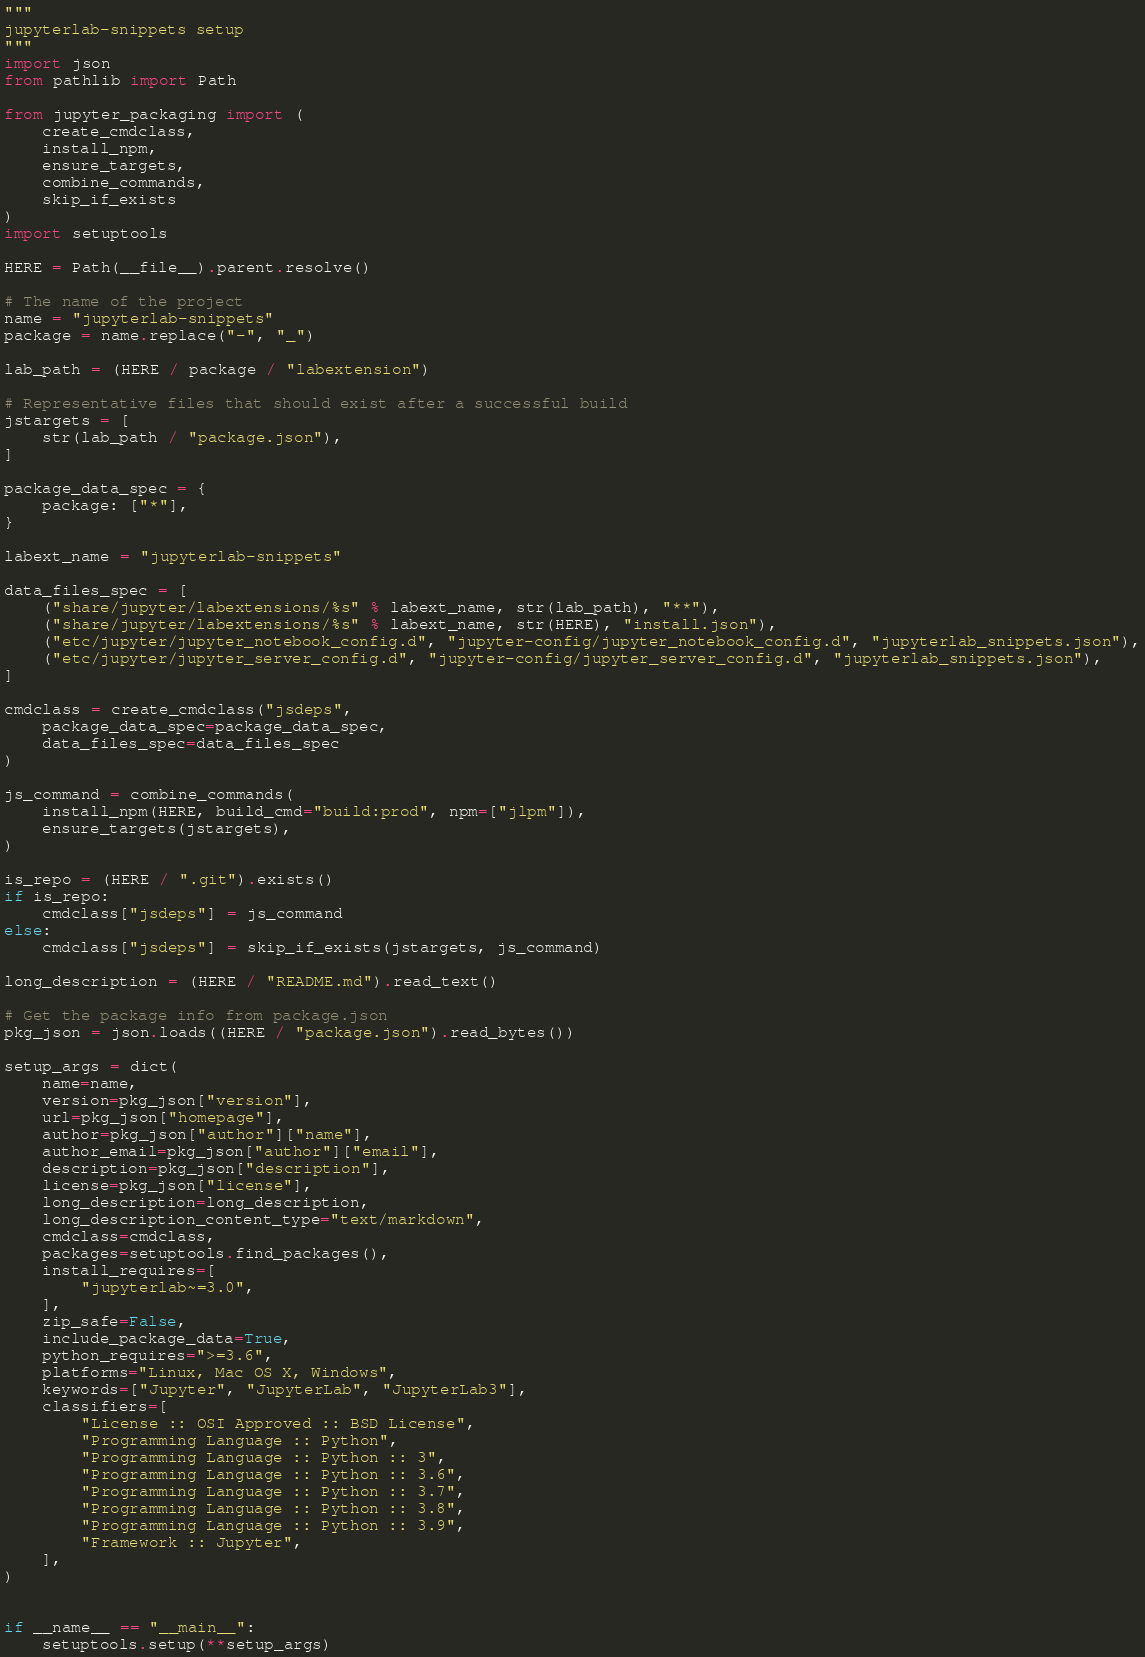<code> <loc_0><loc_0><loc_500><loc_500><_Python_>"""
jupyterlab-snippets setup
"""
import json
from pathlib import Path

from jupyter_packaging import (
    create_cmdclass,
    install_npm,
    ensure_targets,
    combine_commands,
    skip_if_exists
)
import setuptools

HERE = Path(__file__).parent.resolve()

# The name of the project
name = "jupyterlab-snippets"
package = name.replace("-", "_")

lab_path = (HERE / package / "labextension")

# Representative files that should exist after a successful build
jstargets = [
    str(lab_path / "package.json"),
]

package_data_spec = {
    package: ["*"],
}

labext_name = "jupyterlab-snippets"

data_files_spec = [
    ("share/jupyter/labextensions/%s" % labext_name, str(lab_path), "**"),
    ("share/jupyter/labextensions/%s" % labext_name, str(HERE), "install.json"),
    ("etc/jupyter/jupyter_notebook_config.d", "jupyter-config/jupyter_notebook_config.d", "jupyterlab_snippets.json"),
    ("etc/jupyter/jupyter_server_config.d", "jupyter-config/jupyter_server_config.d", "jupyterlab_snippets.json"),
]

cmdclass = create_cmdclass("jsdeps",
    package_data_spec=package_data_spec,
    data_files_spec=data_files_spec
)

js_command = combine_commands(
    install_npm(HERE, build_cmd="build:prod", npm=["jlpm"]),
    ensure_targets(jstargets),
)

is_repo = (HERE / ".git").exists()
if is_repo:
    cmdclass["jsdeps"] = js_command
else:
    cmdclass["jsdeps"] = skip_if_exists(jstargets, js_command)

long_description = (HERE / "README.md").read_text()

# Get the package info from package.json
pkg_json = json.loads((HERE / "package.json").read_bytes())

setup_args = dict(
    name=name,
    version=pkg_json["version"],
    url=pkg_json["homepage"],
    author=pkg_json["author"]["name"],
    author_email=pkg_json["author"]["email"],
    description=pkg_json["description"],
    license=pkg_json["license"],
    long_description=long_description,
    long_description_content_type="text/markdown",
    cmdclass=cmdclass,
    packages=setuptools.find_packages(),
    install_requires=[
        "jupyterlab~=3.0",
    ],
    zip_safe=False,
    include_package_data=True,
    python_requires=">=3.6",
    platforms="Linux, Mac OS X, Windows",
    keywords=["Jupyter", "JupyterLab", "JupyterLab3"],
    classifiers=[
        "License :: OSI Approved :: BSD License",
        "Programming Language :: Python",
        "Programming Language :: Python :: 3",
        "Programming Language :: Python :: 3.6",
        "Programming Language :: Python :: 3.7",
        "Programming Language :: Python :: 3.8",
        "Programming Language :: Python :: 3.9",
        "Framework :: Jupyter",
    ],
)


if __name__ == "__main__":
    setuptools.setup(**setup_args)
</code> 